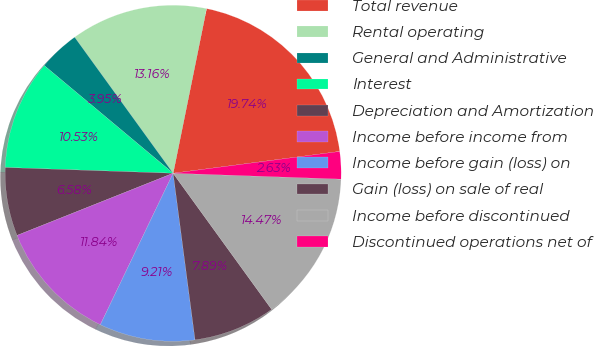<chart> <loc_0><loc_0><loc_500><loc_500><pie_chart><fcel>Total revenue<fcel>Rental operating<fcel>General and Administrative<fcel>Interest<fcel>Depreciation and Amortization<fcel>Income before income from<fcel>Income before gain (loss) on<fcel>Gain (loss) on sale of real<fcel>Income before discontinued<fcel>Discontinued operations net of<nl><fcel>19.74%<fcel>13.16%<fcel>3.95%<fcel>10.53%<fcel>6.58%<fcel>11.84%<fcel>9.21%<fcel>7.89%<fcel>14.47%<fcel>2.63%<nl></chart> 